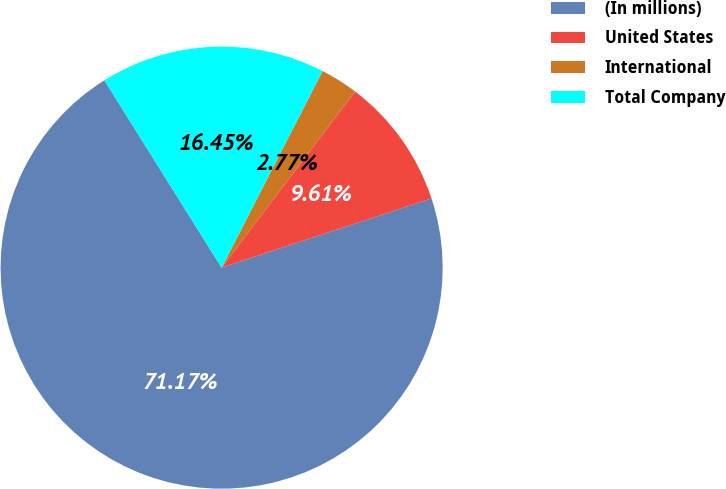Convert chart. <chart><loc_0><loc_0><loc_500><loc_500><pie_chart><fcel>(In millions)<fcel>United States<fcel>International<fcel>Total Company<nl><fcel>71.18%<fcel>9.61%<fcel>2.77%<fcel>16.45%<nl></chart> 